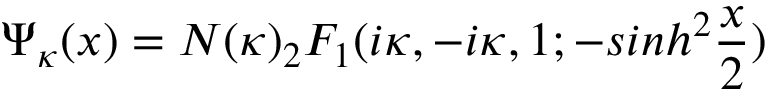Convert formula to latex. <formula><loc_0><loc_0><loc_500><loc_500>\Psi _ { \kappa } ( x ) = N ( \kappa ) _ { 2 } F _ { 1 } ( i \kappa , - i \kappa , 1 ; - \sinh ^ { 2 } \frac { x } { 2 } )</formula> 